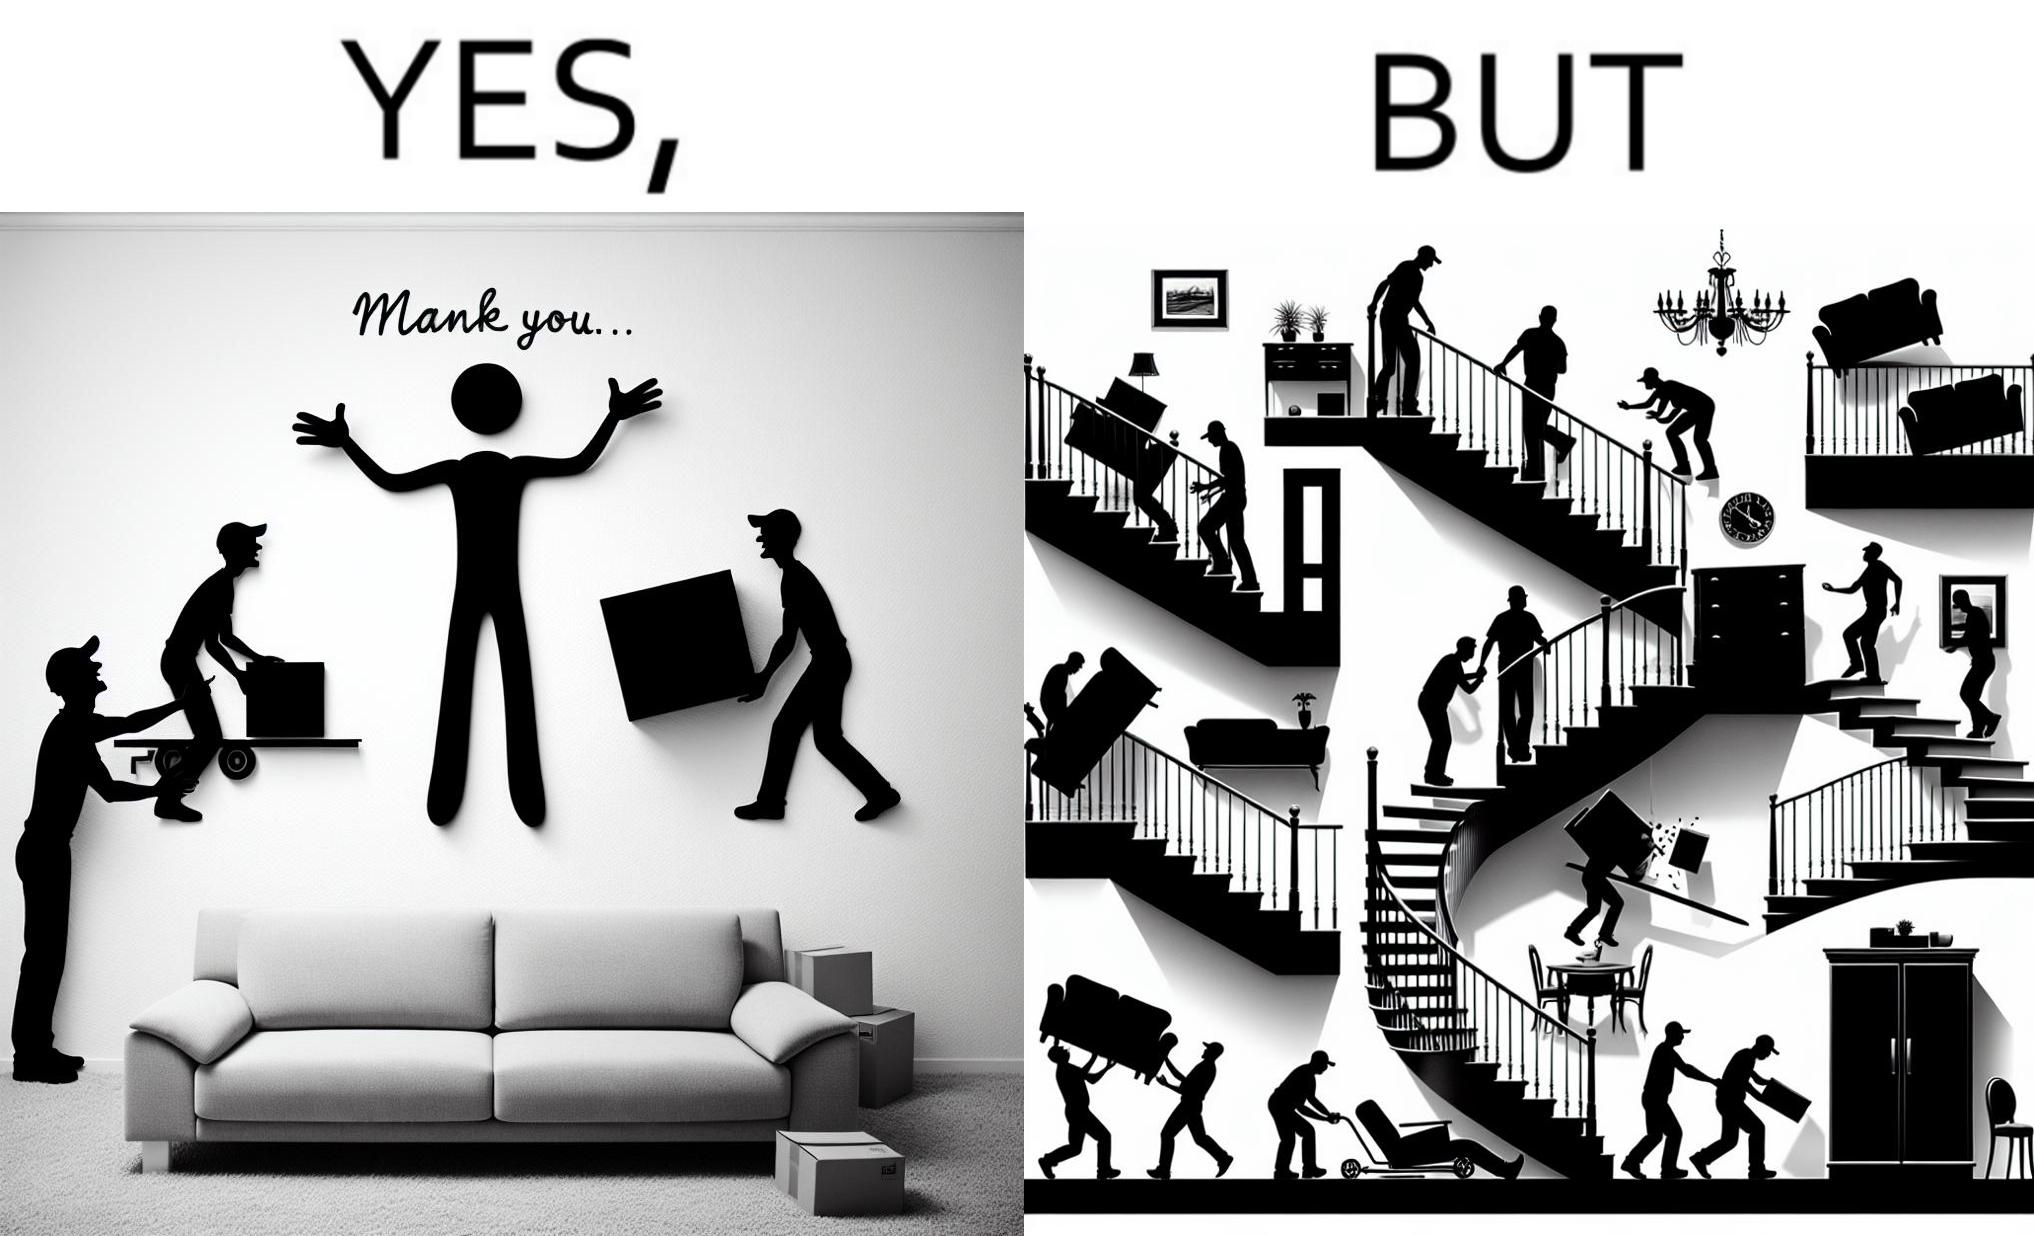Compare the left and right sides of this image. In the left part of the image: A man happy with movers who have helped move in a sofa In the right part of the image: Images show how movers have damaged a house while moving in furniture 